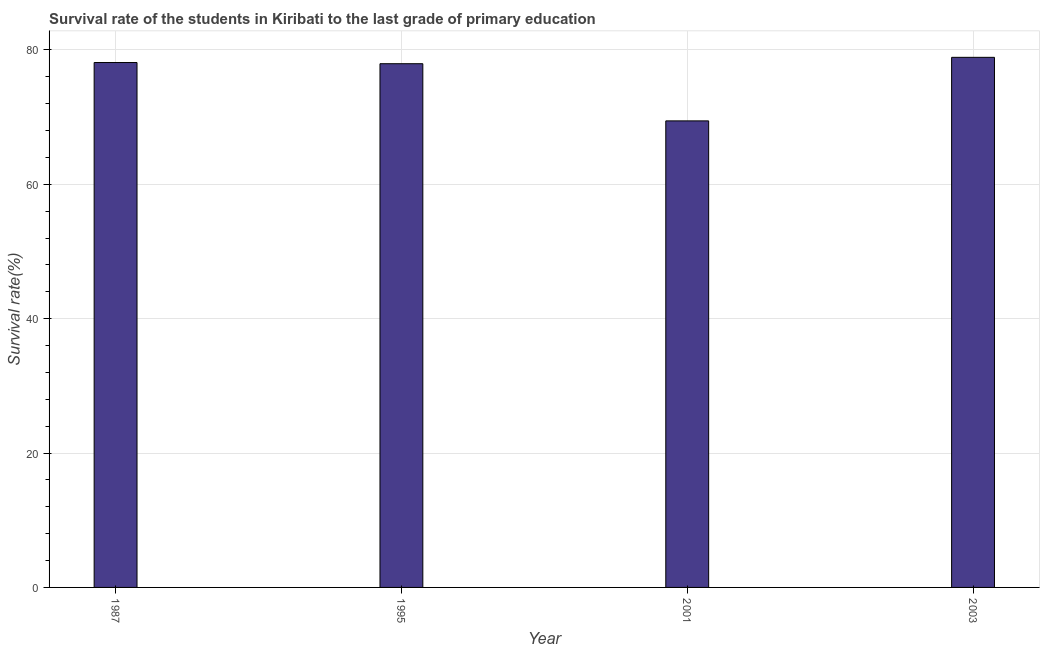Does the graph contain any zero values?
Make the answer very short. No. What is the title of the graph?
Your answer should be very brief. Survival rate of the students in Kiribati to the last grade of primary education. What is the label or title of the Y-axis?
Ensure brevity in your answer.  Survival rate(%). What is the survival rate in primary education in 1995?
Your answer should be compact. 77.96. Across all years, what is the maximum survival rate in primary education?
Your response must be concise. 78.91. Across all years, what is the minimum survival rate in primary education?
Give a very brief answer. 69.45. What is the sum of the survival rate in primary education?
Your answer should be compact. 304.44. What is the difference between the survival rate in primary education in 2001 and 2003?
Give a very brief answer. -9.46. What is the average survival rate in primary education per year?
Provide a short and direct response. 76.11. What is the median survival rate in primary education?
Your answer should be very brief. 78.04. In how many years, is the survival rate in primary education greater than 76 %?
Provide a short and direct response. 3. Do a majority of the years between 2003 and 1987 (inclusive) have survival rate in primary education greater than 36 %?
Provide a succinct answer. Yes. What is the ratio of the survival rate in primary education in 1995 to that in 2001?
Give a very brief answer. 1.12. Is the difference between the survival rate in primary education in 1987 and 2001 greater than the difference between any two years?
Keep it short and to the point. No. What is the difference between the highest and the second highest survival rate in primary education?
Make the answer very short. 0.77. Is the sum of the survival rate in primary education in 1987 and 2003 greater than the maximum survival rate in primary education across all years?
Provide a succinct answer. Yes. What is the difference between the highest and the lowest survival rate in primary education?
Make the answer very short. 9.46. In how many years, is the survival rate in primary education greater than the average survival rate in primary education taken over all years?
Keep it short and to the point. 3. How many bars are there?
Your answer should be very brief. 4. Are all the bars in the graph horizontal?
Offer a very short reply. No. How many years are there in the graph?
Keep it short and to the point. 4. Are the values on the major ticks of Y-axis written in scientific E-notation?
Offer a very short reply. No. What is the Survival rate(%) of 1987?
Offer a very short reply. 78.13. What is the Survival rate(%) of 1995?
Provide a succinct answer. 77.96. What is the Survival rate(%) in 2001?
Provide a succinct answer. 69.45. What is the Survival rate(%) of 2003?
Keep it short and to the point. 78.91. What is the difference between the Survival rate(%) in 1987 and 1995?
Offer a very short reply. 0.18. What is the difference between the Survival rate(%) in 1987 and 2001?
Your response must be concise. 8.69. What is the difference between the Survival rate(%) in 1987 and 2003?
Ensure brevity in your answer.  -0.77. What is the difference between the Survival rate(%) in 1995 and 2001?
Make the answer very short. 8.51. What is the difference between the Survival rate(%) in 1995 and 2003?
Offer a very short reply. -0.95. What is the difference between the Survival rate(%) in 2001 and 2003?
Offer a terse response. -9.46. What is the ratio of the Survival rate(%) in 1987 to that in 1995?
Offer a terse response. 1. What is the ratio of the Survival rate(%) in 1987 to that in 2001?
Make the answer very short. 1.12. What is the ratio of the Survival rate(%) in 1987 to that in 2003?
Your response must be concise. 0.99. What is the ratio of the Survival rate(%) in 1995 to that in 2001?
Provide a succinct answer. 1.12. 